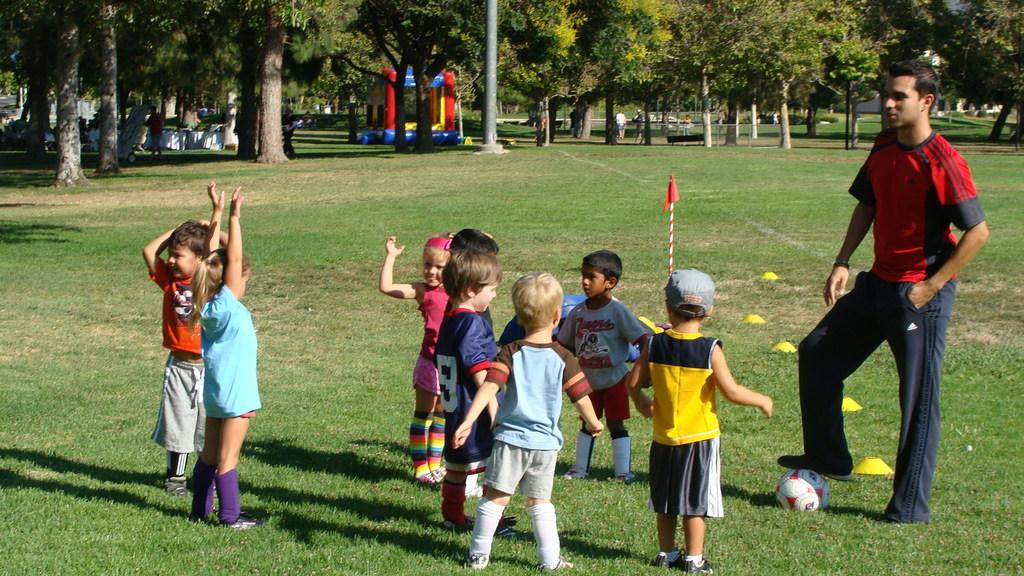What is the primary feature of the land in the image? The land is covered with grass. Can you describe the people in the image? There is a person and children in the image. What object is visible in the image? There is a ball in the image. What can be seen in the background of the image? There are trees, an inflatable object, people, a bench, and a signboard in the background of the image. What type of oatmeal is being served at the protest in the image? There is no protest or oatmeal present in the image. How are the people in the image transporting themselves to the event? There is no event or transportation mentioned in the image; it simply shows people on the grass with a ball. 